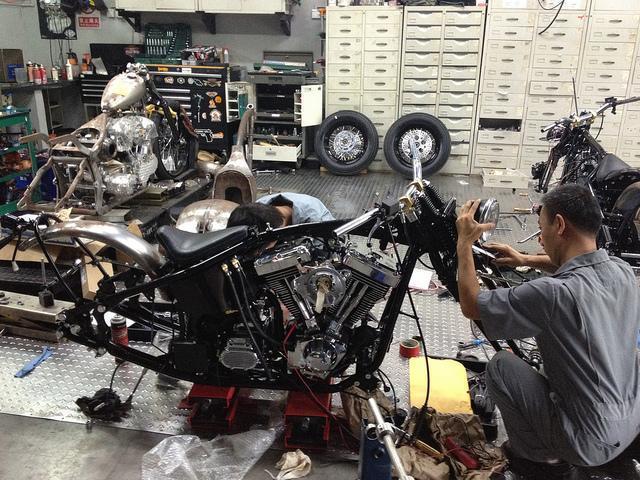What are the cabinets in the background called?
Make your selection and explain in format: 'Answer: answer
Rationale: rationale.'
Options: Safety cabinets, tool cabinets, safes, file cabinets. Answer: safes.
Rationale: This is a mechanic shop so there should be tools in the cabinets. 